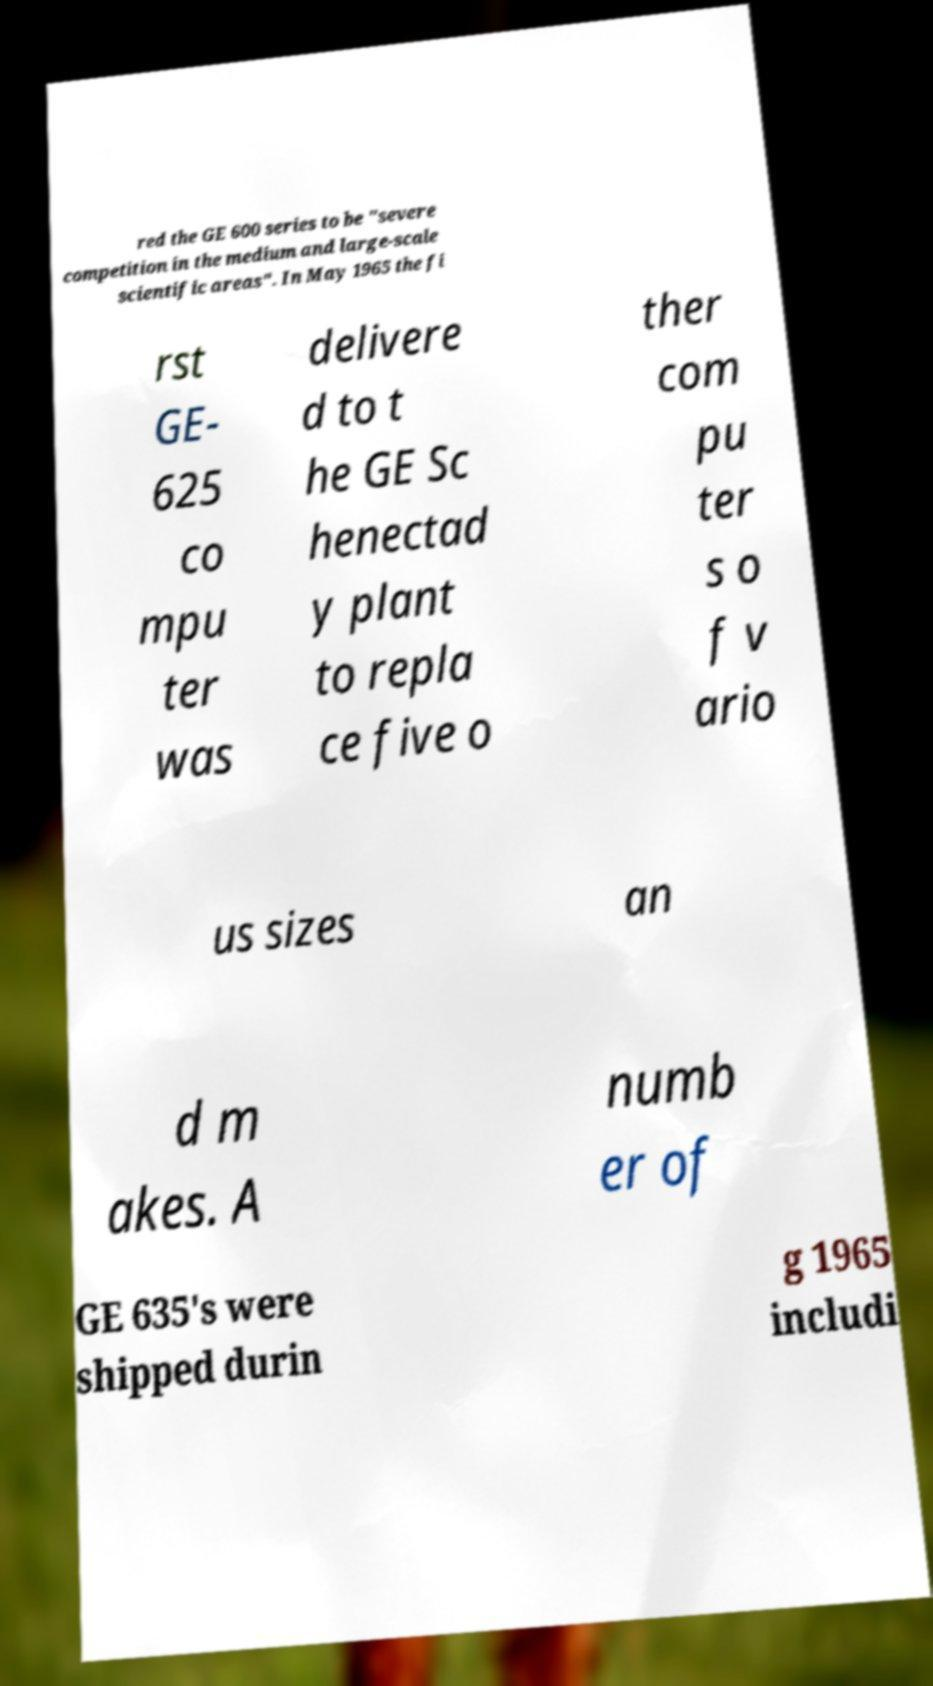For documentation purposes, I need the text within this image transcribed. Could you provide that? red the GE 600 series to be "severe competition in the medium and large-scale scientific areas". In May 1965 the fi rst GE- 625 co mpu ter was delivere d to t he GE Sc henectad y plant to repla ce five o ther com pu ter s o f v ario us sizes an d m akes. A numb er of GE 635's were shipped durin g 1965 includi 